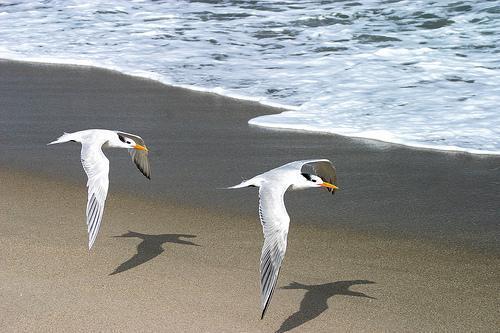How many birds are shown?
Give a very brief answer. 2. 